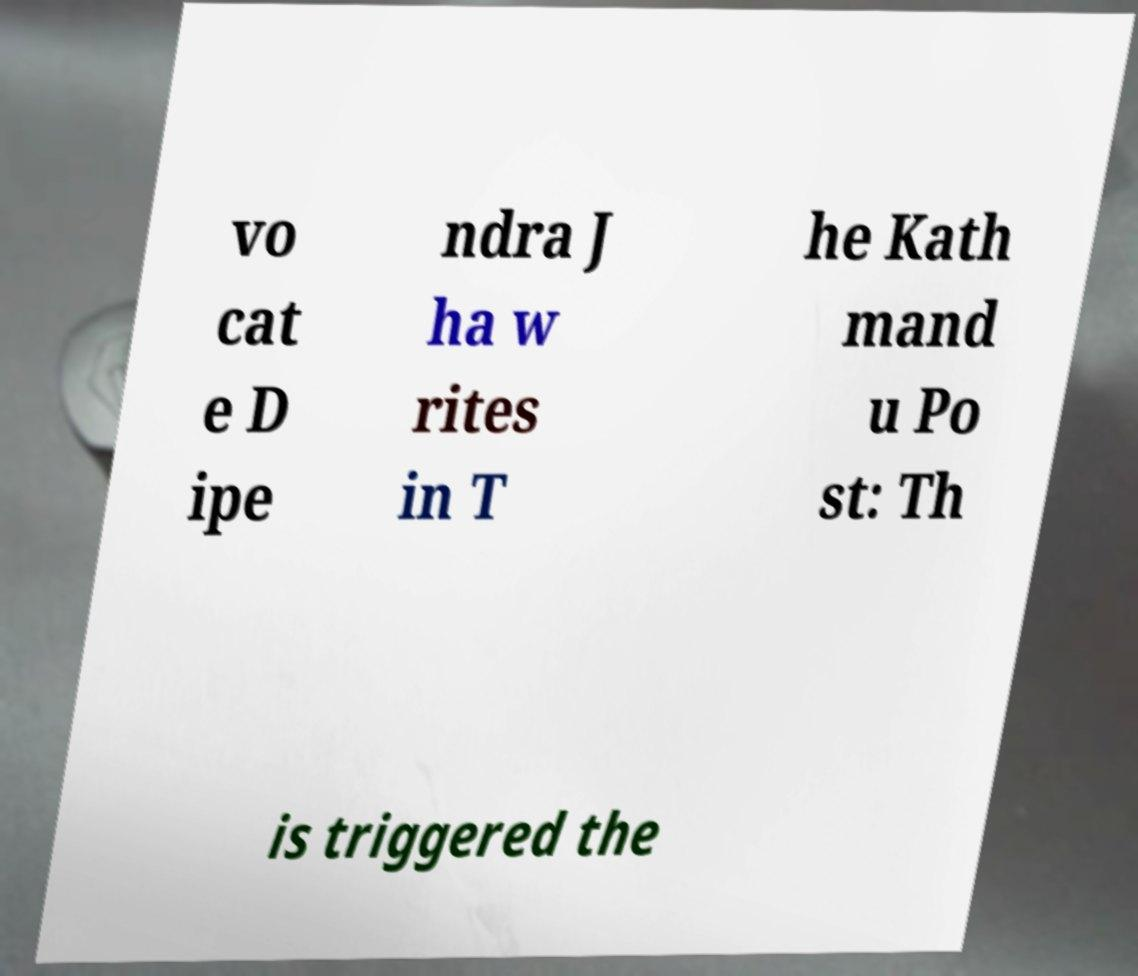Can you accurately transcribe the text from the provided image for me? vo cat e D ipe ndra J ha w rites in T he Kath mand u Po st: Th is triggered the 